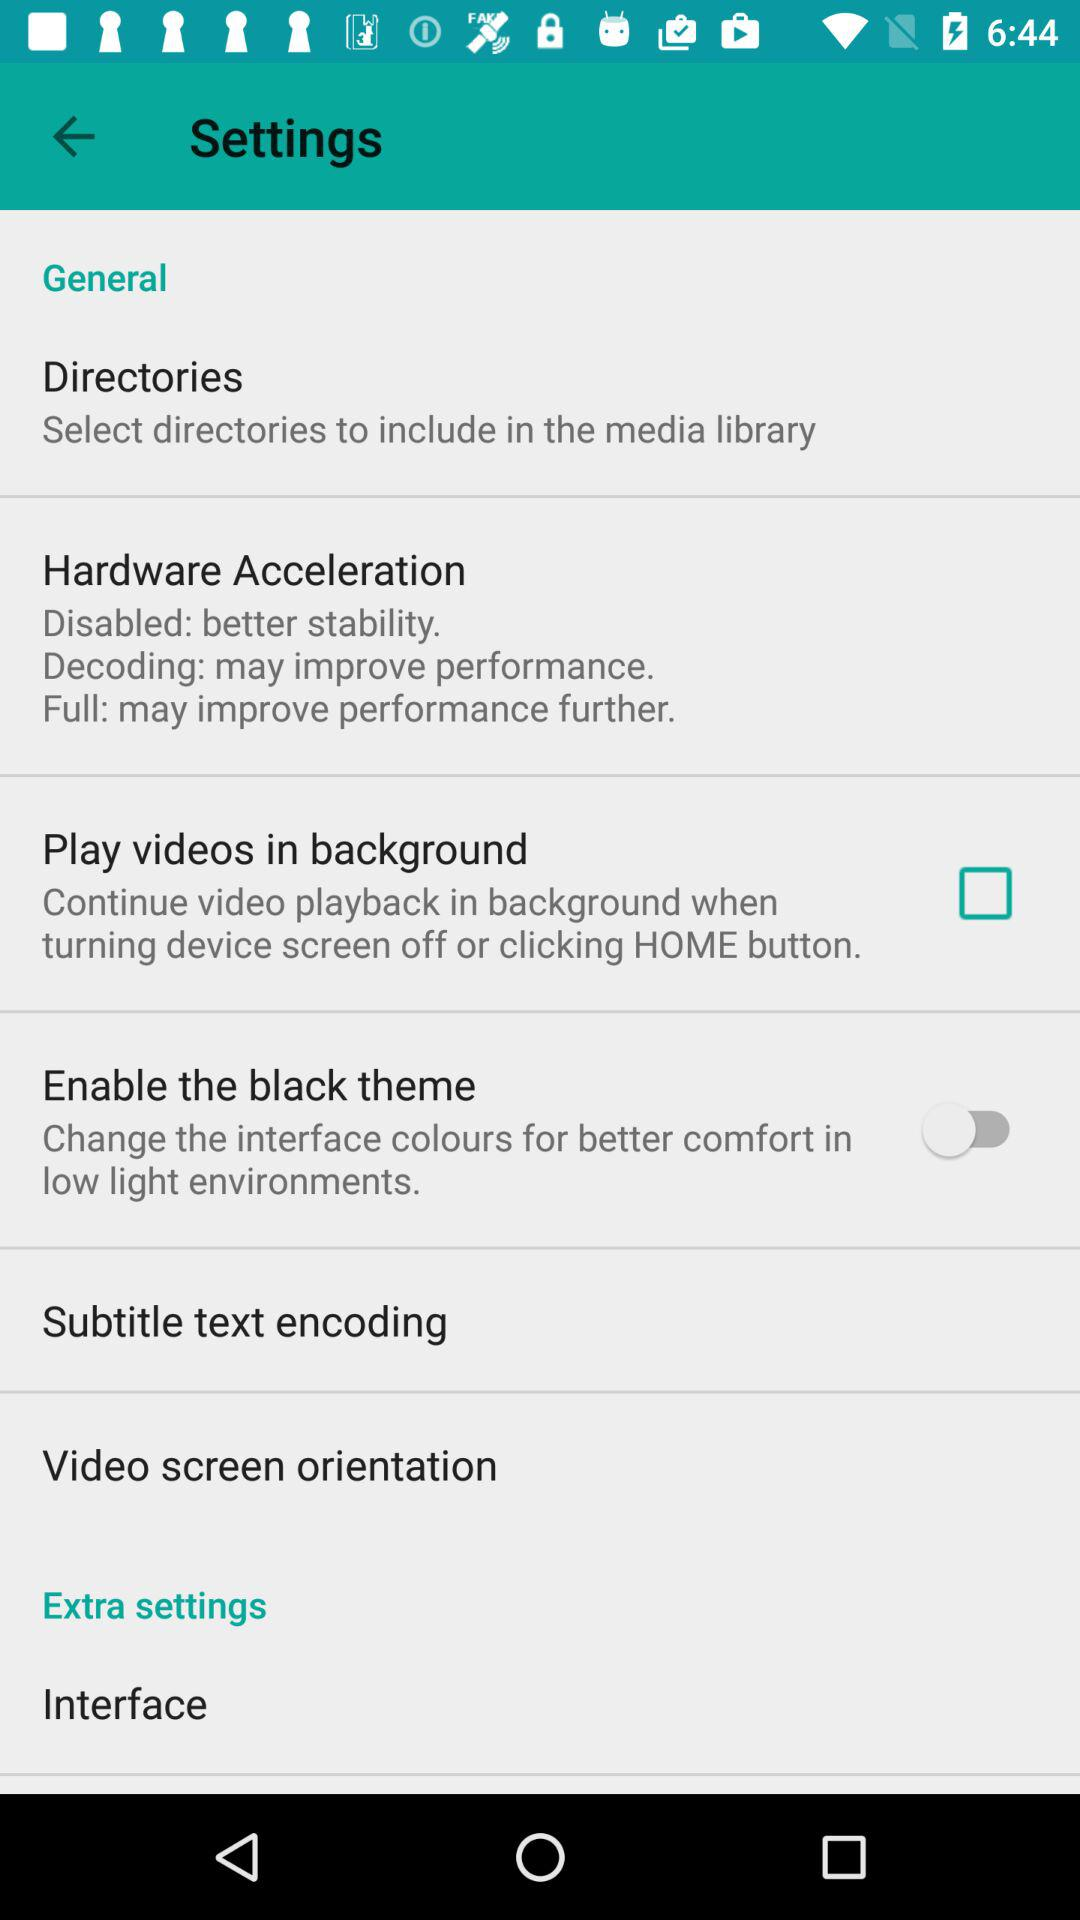What's the status of "Enable the black theme"? The status is "off". 